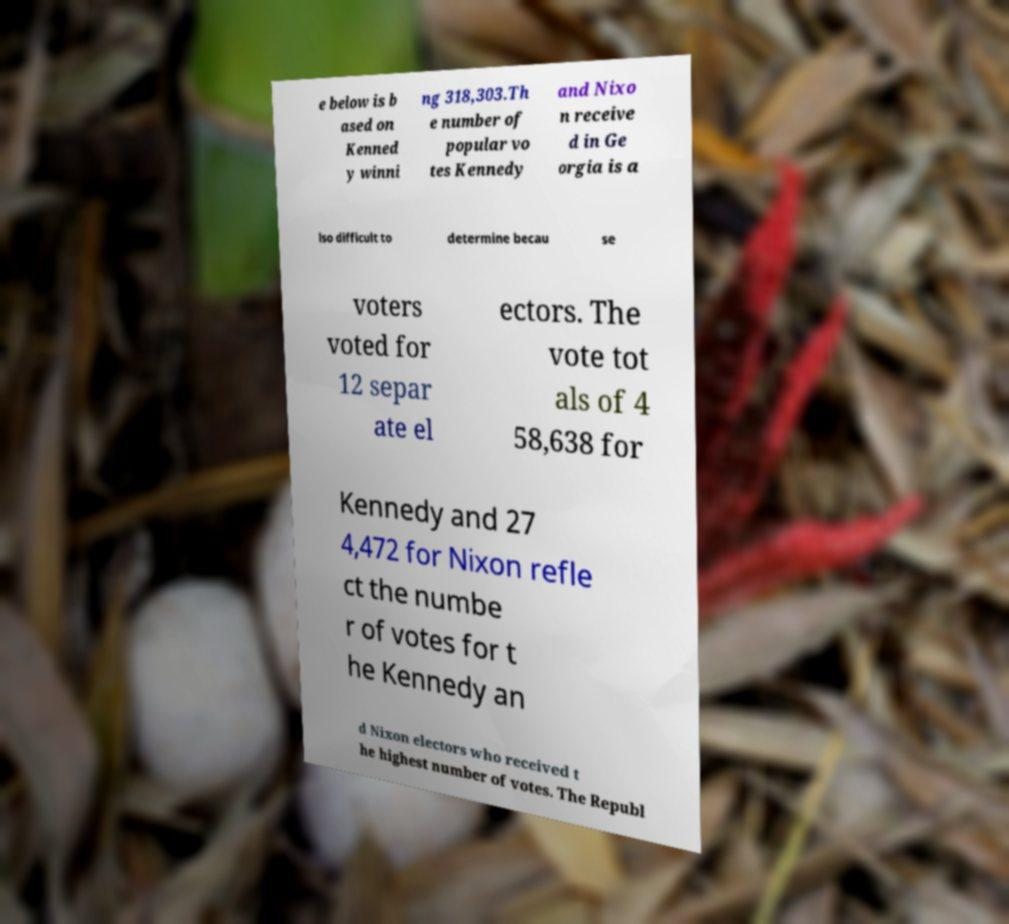What messages or text are displayed in this image? I need them in a readable, typed format. e below is b ased on Kenned y winni ng 318,303.Th e number of popular vo tes Kennedy and Nixo n receive d in Ge orgia is a lso difficult to determine becau se voters voted for 12 separ ate el ectors. The vote tot als of 4 58,638 for Kennedy and 27 4,472 for Nixon refle ct the numbe r of votes for t he Kennedy an d Nixon electors who received t he highest number of votes. The Republ 